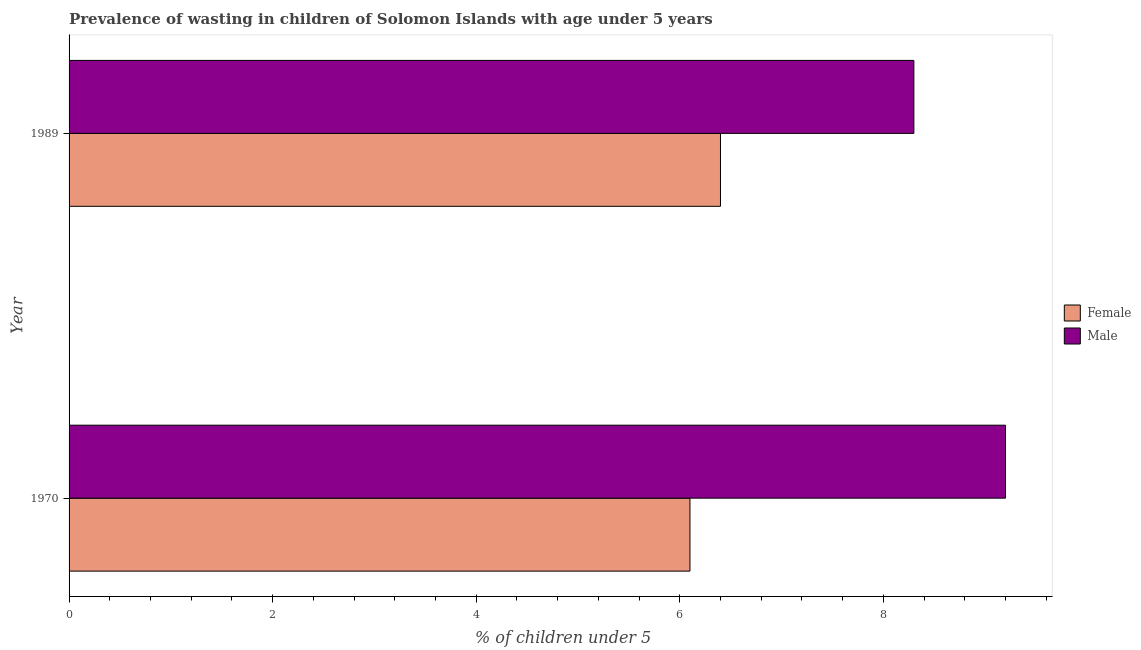How many different coloured bars are there?
Your response must be concise. 2. How many groups of bars are there?
Give a very brief answer. 2. What is the percentage of undernourished female children in 1989?
Your answer should be very brief. 6.4. Across all years, what is the maximum percentage of undernourished male children?
Your response must be concise. 9.2. Across all years, what is the minimum percentage of undernourished male children?
Your answer should be compact. 8.3. In which year was the percentage of undernourished female children maximum?
Provide a succinct answer. 1989. In which year was the percentage of undernourished female children minimum?
Offer a terse response. 1970. What is the total percentage of undernourished male children in the graph?
Offer a terse response. 17.5. What is the difference between the percentage of undernourished male children in 1989 and the percentage of undernourished female children in 1970?
Your response must be concise. 2.2. What is the average percentage of undernourished male children per year?
Give a very brief answer. 8.75. In the year 1970, what is the difference between the percentage of undernourished male children and percentage of undernourished female children?
Your answer should be compact. 3.1. In how many years, is the percentage of undernourished female children greater than 8.8 %?
Your answer should be very brief. 0. What is the ratio of the percentage of undernourished male children in 1970 to that in 1989?
Offer a terse response. 1.11. Is the percentage of undernourished female children in 1970 less than that in 1989?
Keep it short and to the point. Yes. Is the difference between the percentage of undernourished female children in 1970 and 1989 greater than the difference between the percentage of undernourished male children in 1970 and 1989?
Your response must be concise. No. What does the 2nd bar from the top in 1970 represents?
Offer a terse response. Female. What does the 1st bar from the bottom in 1989 represents?
Make the answer very short. Female. How many bars are there?
Offer a very short reply. 4. Are all the bars in the graph horizontal?
Make the answer very short. Yes. Are the values on the major ticks of X-axis written in scientific E-notation?
Provide a succinct answer. No. Does the graph contain any zero values?
Your response must be concise. No. Does the graph contain grids?
Provide a succinct answer. No. How many legend labels are there?
Offer a terse response. 2. What is the title of the graph?
Offer a very short reply. Prevalence of wasting in children of Solomon Islands with age under 5 years. What is the label or title of the X-axis?
Make the answer very short.  % of children under 5. What is the label or title of the Y-axis?
Provide a short and direct response. Year. What is the  % of children under 5 in Female in 1970?
Make the answer very short. 6.1. What is the  % of children under 5 in Male in 1970?
Your answer should be compact. 9.2. What is the  % of children under 5 of Female in 1989?
Offer a very short reply. 6.4. What is the  % of children under 5 of Male in 1989?
Offer a terse response. 8.3. Across all years, what is the maximum  % of children under 5 of Female?
Offer a very short reply. 6.4. Across all years, what is the maximum  % of children under 5 in Male?
Give a very brief answer. 9.2. Across all years, what is the minimum  % of children under 5 in Female?
Make the answer very short. 6.1. Across all years, what is the minimum  % of children under 5 of Male?
Provide a succinct answer. 8.3. What is the difference between the  % of children under 5 of Female in 1970 and that in 1989?
Offer a very short reply. -0.3. What is the difference between the  % of children under 5 in Male in 1970 and that in 1989?
Provide a succinct answer. 0.9. What is the difference between the  % of children under 5 in Female in 1970 and the  % of children under 5 in Male in 1989?
Ensure brevity in your answer.  -2.2. What is the average  % of children under 5 of Female per year?
Provide a succinct answer. 6.25. What is the average  % of children under 5 of Male per year?
Make the answer very short. 8.75. In the year 1989, what is the difference between the  % of children under 5 in Female and  % of children under 5 in Male?
Offer a very short reply. -1.9. What is the ratio of the  % of children under 5 of Female in 1970 to that in 1989?
Ensure brevity in your answer.  0.95. What is the ratio of the  % of children under 5 of Male in 1970 to that in 1989?
Offer a terse response. 1.11. What is the difference between the highest and the second highest  % of children under 5 in Male?
Your answer should be compact. 0.9. What is the difference between the highest and the lowest  % of children under 5 of Female?
Provide a succinct answer. 0.3. What is the difference between the highest and the lowest  % of children under 5 of Male?
Your response must be concise. 0.9. 